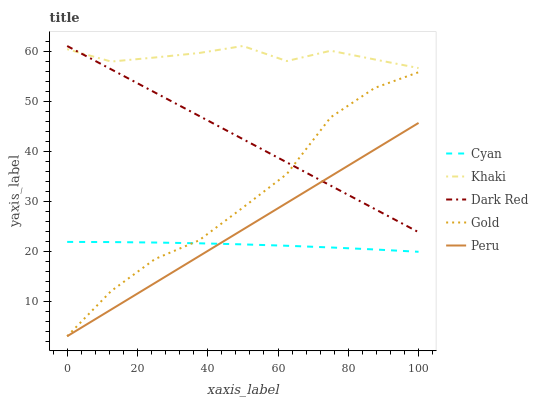Does Cyan have the minimum area under the curve?
Answer yes or no. Yes. Does Khaki have the maximum area under the curve?
Answer yes or no. Yes. Does Peru have the minimum area under the curve?
Answer yes or no. No. Does Peru have the maximum area under the curve?
Answer yes or no. No. Is Peru the smoothest?
Answer yes or no. Yes. Is Gold the roughest?
Answer yes or no. Yes. Is Khaki the smoothest?
Answer yes or no. No. Is Khaki the roughest?
Answer yes or no. No. Does Peru have the lowest value?
Answer yes or no. Yes. Does Khaki have the lowest value?
Answer yes or no. No. Does Dark Red have the highest value?
Answer yes or no. Yes. Does Peru have the highest value?
Answer yes or no. No. Is Cyan less than Khaki?
Answer yes or no. Yes. Is Khaki greater than Peru?
Answer yes or no. Yes. Does Dark Red intersect Khaki?
Answer yes or no. Yes. Is Dark Red less than Khaki?
Answer yes or no. No. Is Dark Red greater than Khaki?
Answer yes or no. No. Does Cyan intersect Khaki?
Answer yes or no. No. 